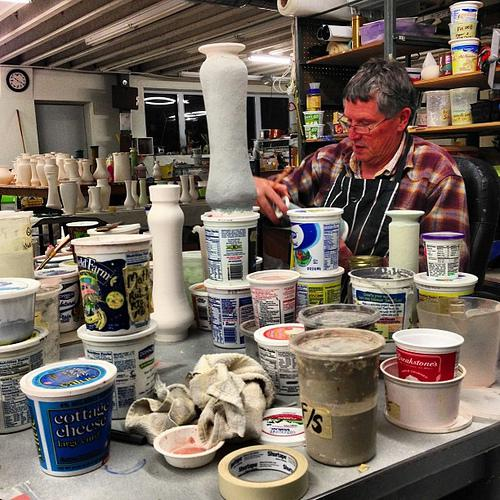Question: what is the man doing?
Choices:
A. Basket weaving.
B. Paper mache.
C. Fingerpainting.
D. Pottery.
Answer with the letter. Answer: D Question: what is the man wearing on his face?
Choices:
A. Glasses.
B. Clown nose.
C. Halloween mask.
D. Bandana.
Answer with the letter. Answer: A Question: where is the man sitting?
Choices:
A. On a chair.
B. Bed.
C. Floor.
D. Rug.
Answer with the letter. Answer: A Question: how many of the man's fingers are visible?
Choices:
A. Three.
B. Five.
C. One.
D. Four.
Answer with the letter. Answer: A Question: what is written on the front container's masking tape?
Choices:
A. F/S.
B. Fragile.
C. This end up.
D. Do not drop.
Answer with the letter. Answer: A Question: what kind of tape is on the table?
Choices:
A. Duct tape.
B. Masking tape.
C. Packing tape.
D. Electrical tape.
Answer with the letter. Answer: B 